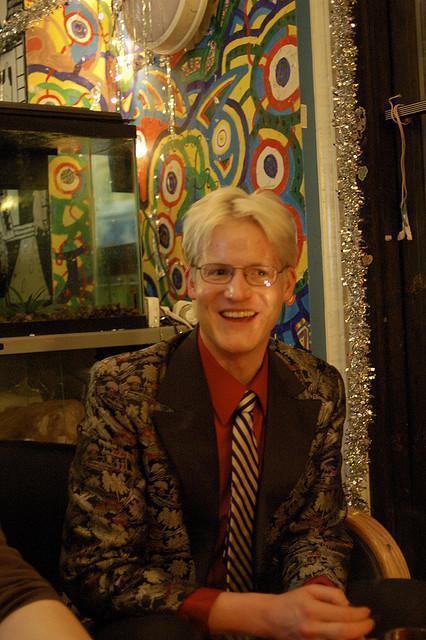What is the gold lining in the doorway called?
Make your selection and explain in format: 'Answer: answer
Rationale: rationale.'
Options: Gold leaf, tinsel, plastic, ermine. Answer: ermine.
Rationale: The gold lining is often known as ermine. 